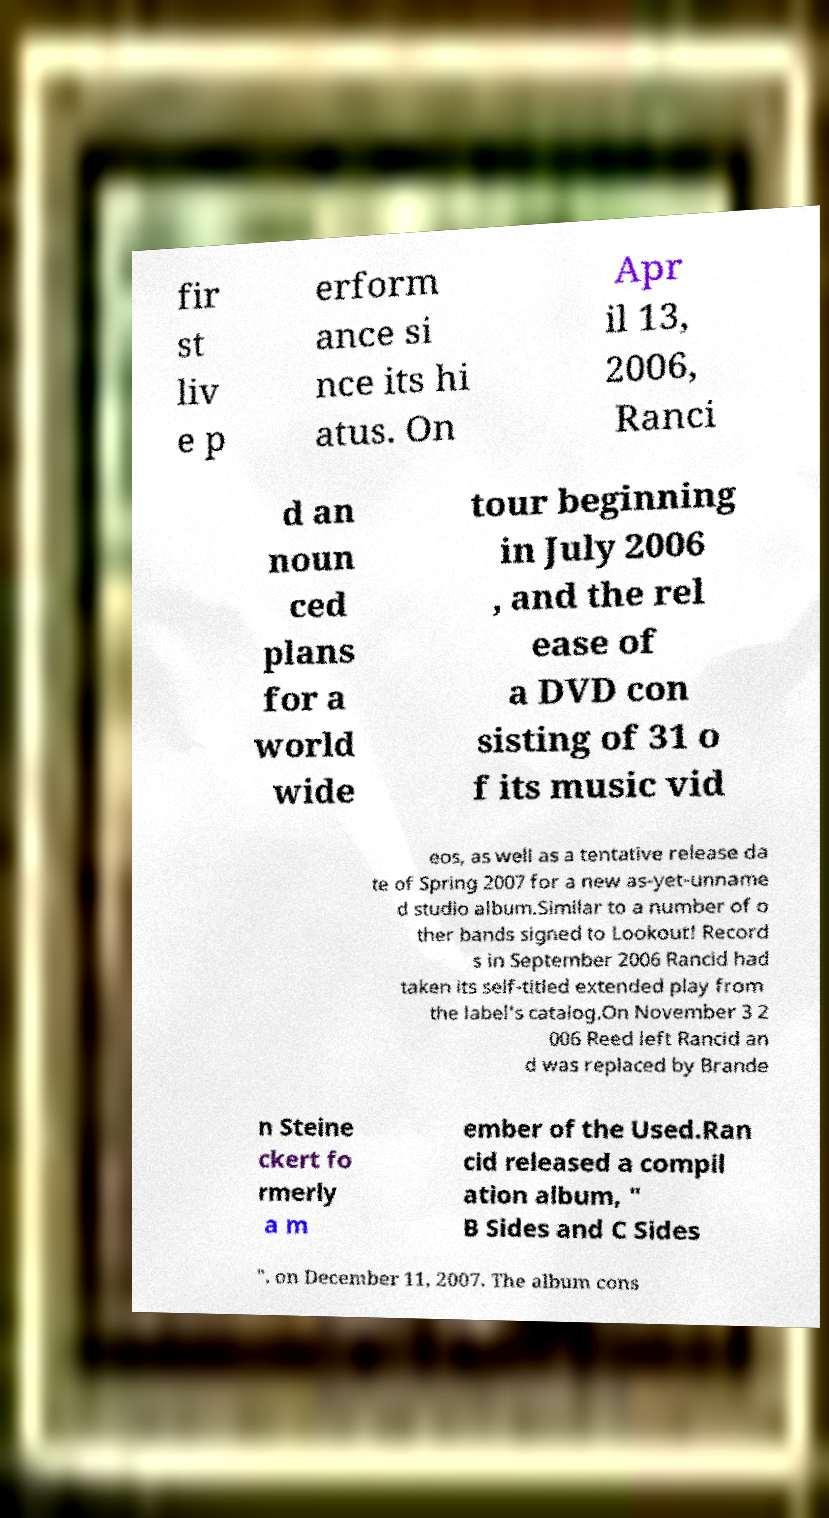Please identify and transcribe the text found in this image. fir st liv e p erform ance si nce its hi atus. On Apr il 13, 2006, Ranci d an noun ced plans for a world wide tour beginning in July 2006 , and the rel ease of a DVD con sisting of 31 o f its music vid eos, as well as a tentative release da te of Spring 2007 for a new as-yet-unname d studio album.Similar to a number of o ther bands signed to Lookout! Record s in September 2006 Rancid had taken its self-titled extended play from the label's catalog.On November 3 2 006 Reed left Rancid an d was replaced by Brande n Steine ckert fo rmerly a m ember of the Used.Ran cid released a compil ation album, " B Sides and C Sides ", on December 11, 2007. The album cons 